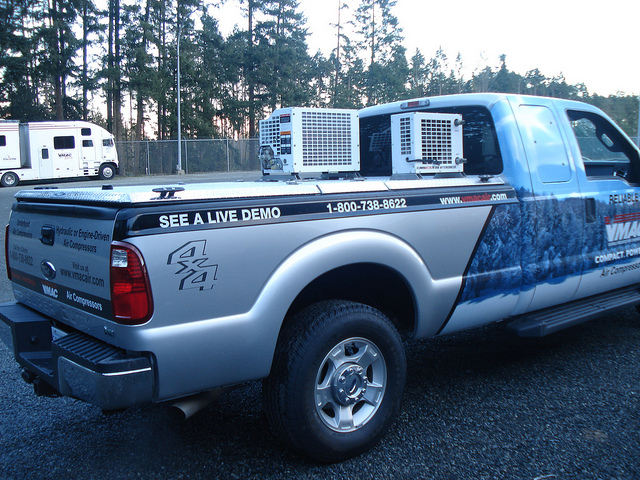Please transcribe the text in this image. SEE A LIVE DEMO 1-800-738-8622 VMA 4x4 Engine 